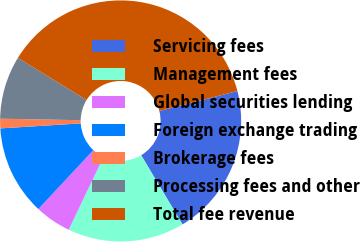Convert chart to OTSL. <chart><loc_0><loc_0><loc_500><loc_500><pie_chart><fcel>Servicing fees<fcel>Management fees<fcel>Global securities lending<fcel>Foreign exchange trading<fcel>Brokerage fees<fcel>Processing fees and other<fcel>Total fee revenue<nl><fcel>20.42%<fcel>15.66%<fcel>4.87%<fcel>12.06%<fcel>1.28%<fcel>8.47%<fcel>37.24%<nl></chart> 